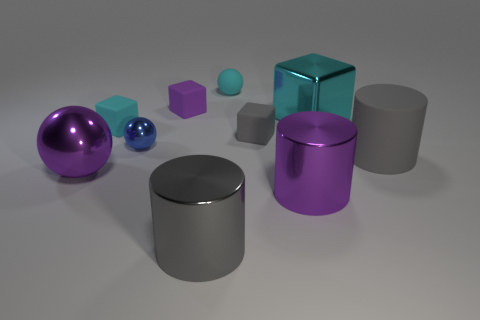Subtract all cylinders. How many objects are left? 7 Subtract 0 blue blocks. How many objects are left? 10 Subtract all small cyan blocks. Subtract all purple cubes. How many objects are left? 8 Add 7 cyan metallic blocks. How many cyan metallic blocks are left? 8 Add 4 tiny spheres. How many tiny spheres exist? 6 